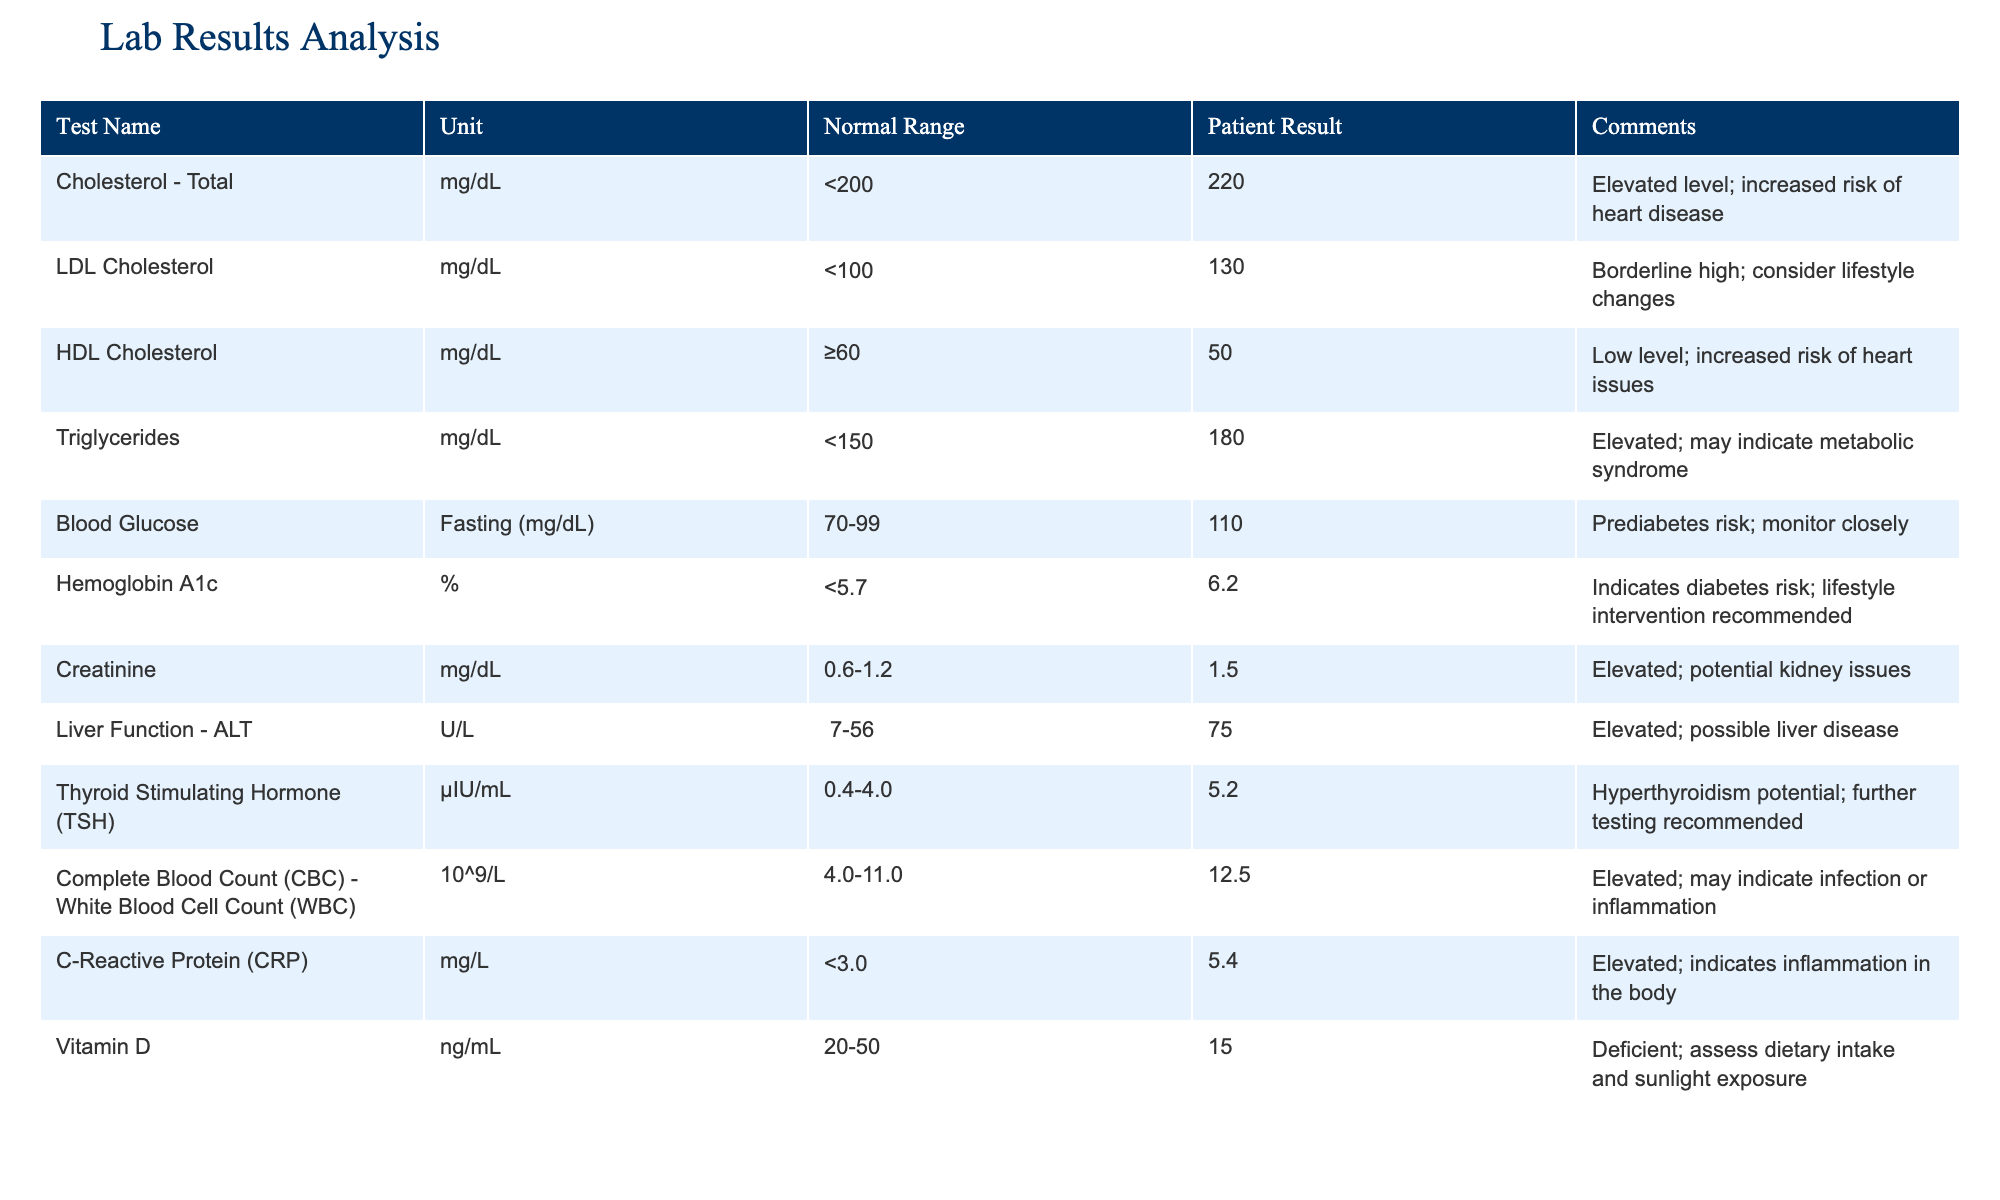What is the patient's total cholesterol level? The table lists the patient's result for total cholesterol as 220 mg/dL. This value is found under the "Patient Result" column for the row labeled "Cholesterol - Total".
Answer: 220 mg/dL Is the patient's HDL cholesterol level within the normal range? The normal range for HDL cholesterol is equal to or greater than 60 mg/dL. The patient's result is 50 mg/dL, which is below the normal range. Thus, the patient's HDL cholesterol level is not within the normal range.
Answer: No What is the difference between the patient's Triglycerides level and the normal upper limit? The normal upper limit for triglycerides is 150 mg/dL, while the patient's level is 180 mg/dL. The difference can be calculated as 180 - 150 = 30 mg/dL.
Answer: 30 mg/dL How many test results indicate elevated risks? The table shows several tests marked as elevated: Total Cholesterol, LDL Cholesterol, Triglycerides, Hemoglobin A1c, Creatinine, ALT, WBC, C-Reactive Protein, and Vitamin D. Counting these gives us 9 tests with elevated risks.
Answer: 9 tests What is the average level of glucose from the normal range? The normal range for fasting blood glucose is 70-99 mg/dL. The average is calculated by summing the lower and upper bounds (70 + 99 = 169) and dividing by 2, which gives us 169/2 = 84.5 mg/dL.
Answer: 84.5 mg/dL Is the C-Reactive Protein level indicating inflammation? The normal limit for C-Reactive Protein is under 3.0 mg/L, but the patient's result is 5.4 mg/L. This indicates elevated inflammation, confirming the question is true.
Answer: Yes What is the median of the patient's lab results? To find the median, first organize the results numerically: 15, 50, 110, 130, 180, 220, 75, 6.2, 1.5, and 12.5. The median is the average of the 5th and 6th values in the ordered list, which are 130 and 180. Therefore, the median is (130 + 180) / 2 = 155 mg/dL.
Answer: 155 mg/dL Which test has the highest elevated risk? After reviewing each test for elevated risk, Total Cholesterol has the highest result at 220 mg/dL, exceeding its normal range of less than 200 mg/dL.
Answer: Cholesterol - Total Why is the Vitamin D level a concern for the patient? The patient's Vitamin D level is reported at 15 ng/mL, which is below the normal range of 20-50 ng/mL. This deficiency can lead to various health issues, making it a concern for the patient's overall health.
Answer: It is below normal 